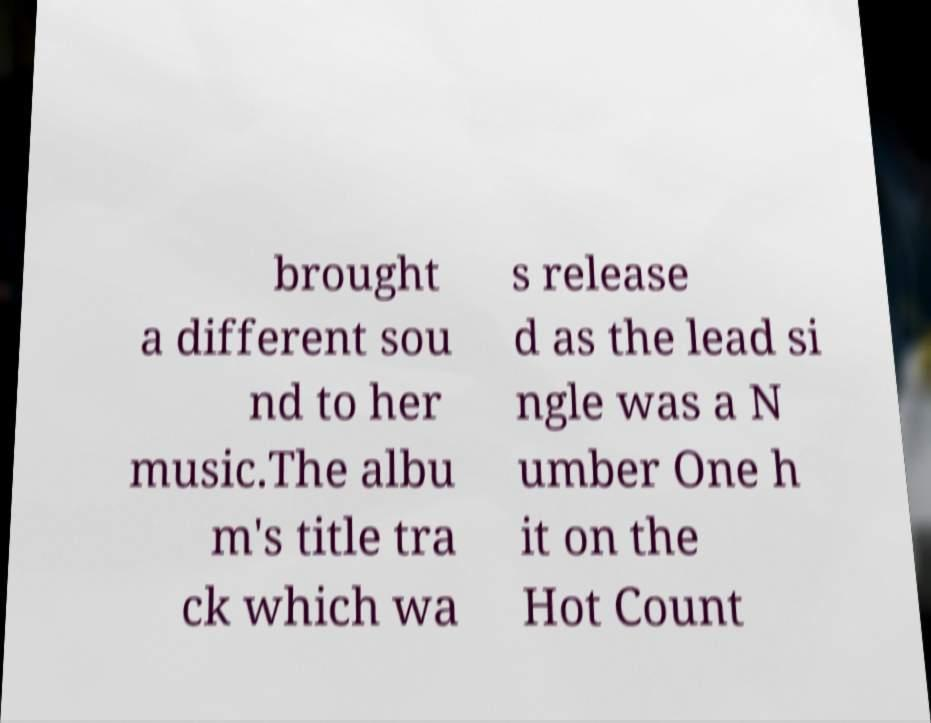Please read and relay the text visible in this image. What does it say? brought a different sou nd to her music.The albu m's title tra ck which wa s release d as the lead si ngle was a N umber One h it on the Hot Count 